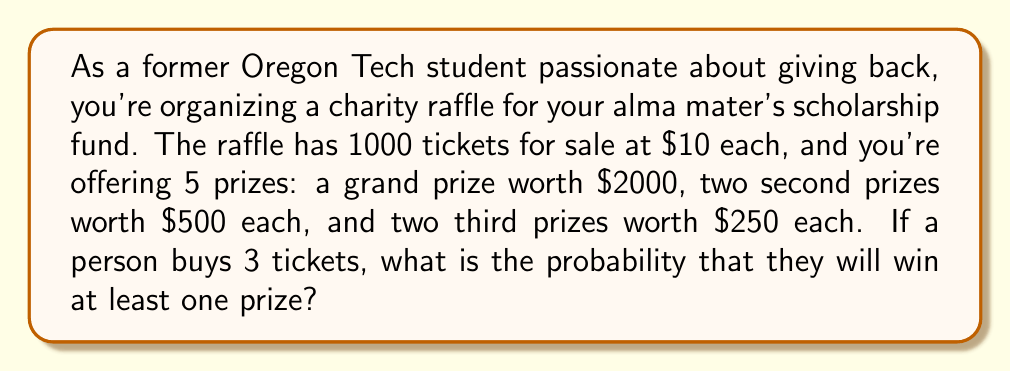Provide a solution to this math problem. Let's approach this step-by-step:

1) First, we need to calculate the probability of not winning any prize with a single ticket. There are 5 prizes out of 1000 tickets, so:

   $P(\text{not winning with one ticket}) = \frac{995}{1000} = 0.995$

2) Now, we need to find the probability of not winning with all 3 tickets. Since the events are independent, we multiply the probabilities:

   $P(\text{not winning with 3 tickets}) = (0.995)^3 = 0.985075125$

3) The probability of winning at least one prize is the complement of not winning any prize:

   $P(\text{winning at least one prize}) = 1 - P(\text{not winning with 3 tickets})$

   $= 1 - 0.985075125 = 0.014924875$

4) To express this as a percentage:

   $0.014924875 \times 100\% = 1.4924875\%$

Therefore, the probability of winning at least one prize with 3 tickets is approximately 1.49%.
Answer: The probability of winning at least one prize with 3 tickets is $0.014924875$ or approximately $1.49\%$. 